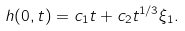Convert formula to latex. <formula><loc_0><loc_0><loc_500><loc_500>h ( 0 , t ) = c _ { 1 } t + c _ { 2 } t ^ { 1 / 3 } \xi _ { 1 } .</formula> 